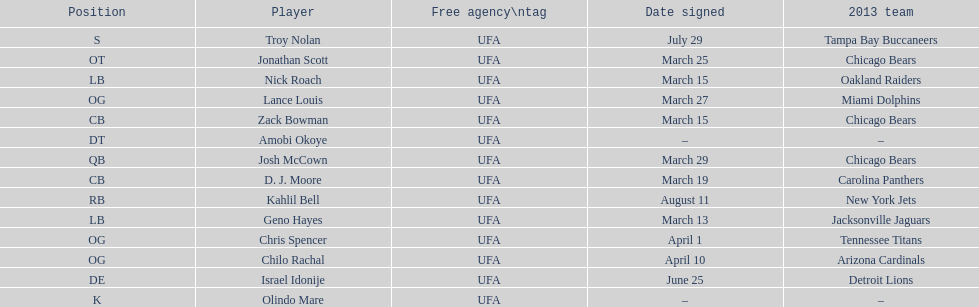Last name is also a first name beginning with "n" Troy Nolan. 